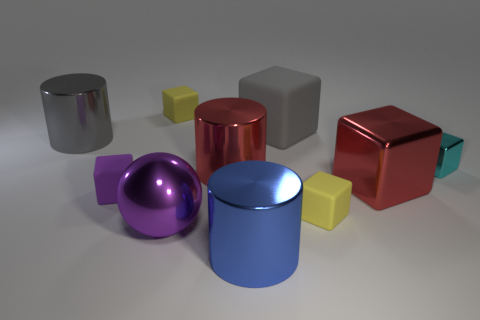What time of day do you think it is based on the lighting in the image? The lighting in the image appears artificial, as indicated by the soft shadows and consistent illumination of the objects, which suggests it's a controlled environment rather than a specific time of day outdoors. 